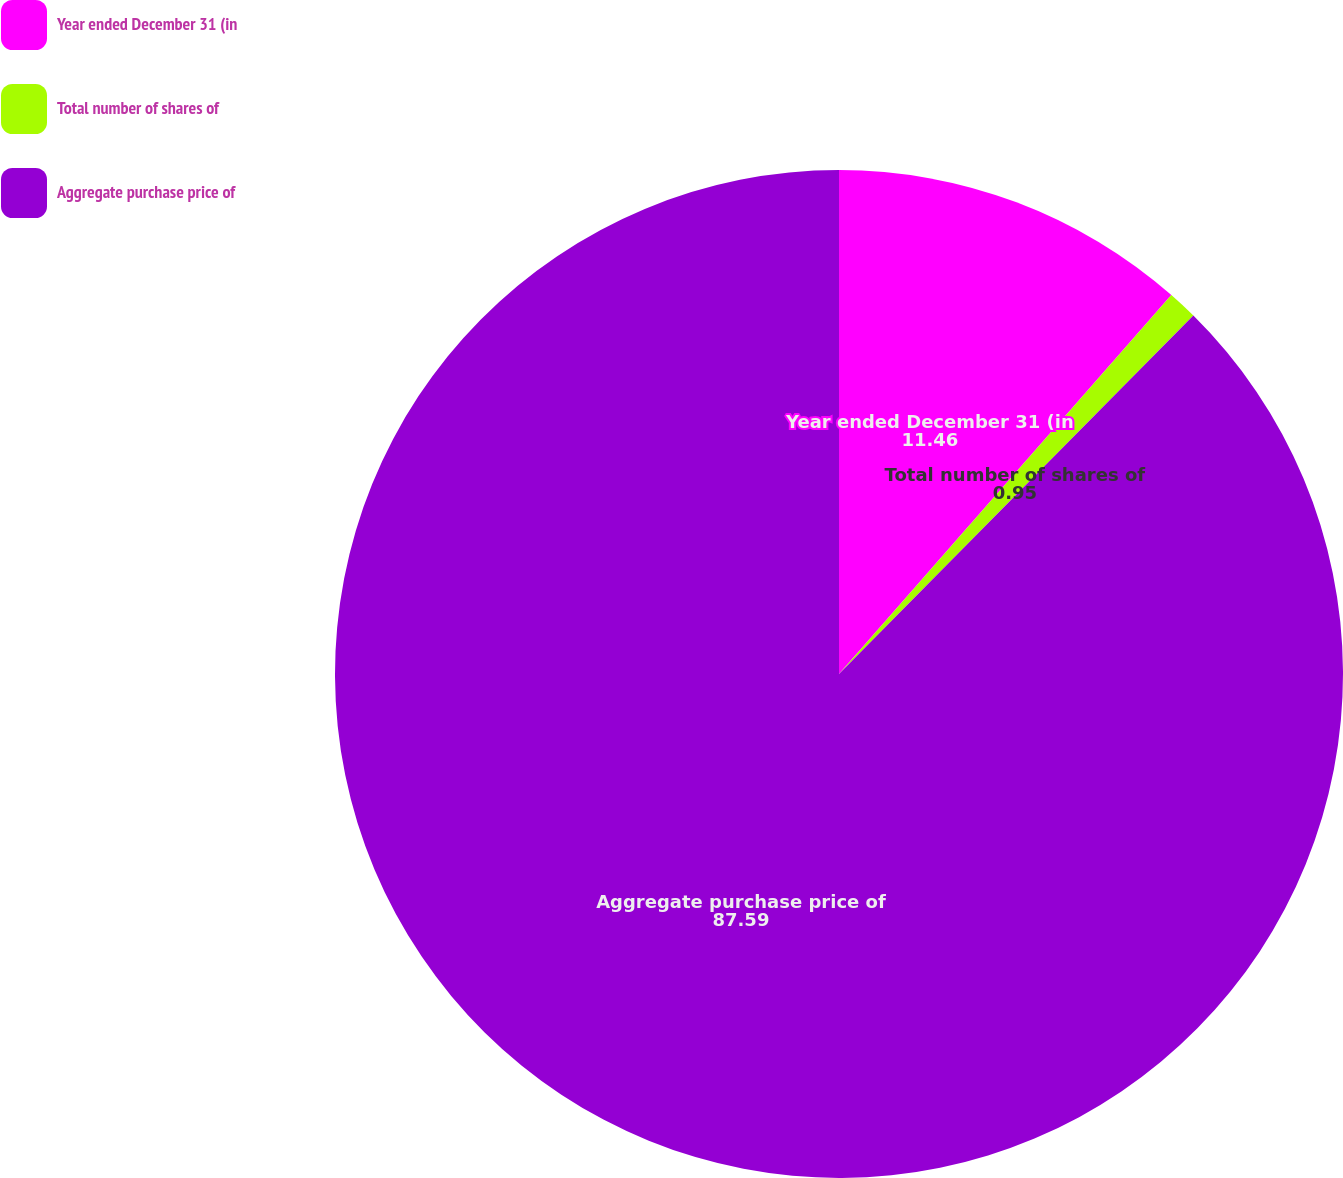Convert chart to OTSL. <chart><loc_0><loc_0><loc_500><loc_500><pie_chart><fcel>Year ended December 31 (in<fcel>Total number of shares of<fcel>Aggregate purchase price of<nl><fcel>11.46%<fcel>0.95%<fcel>87.59%<nl></chart> 